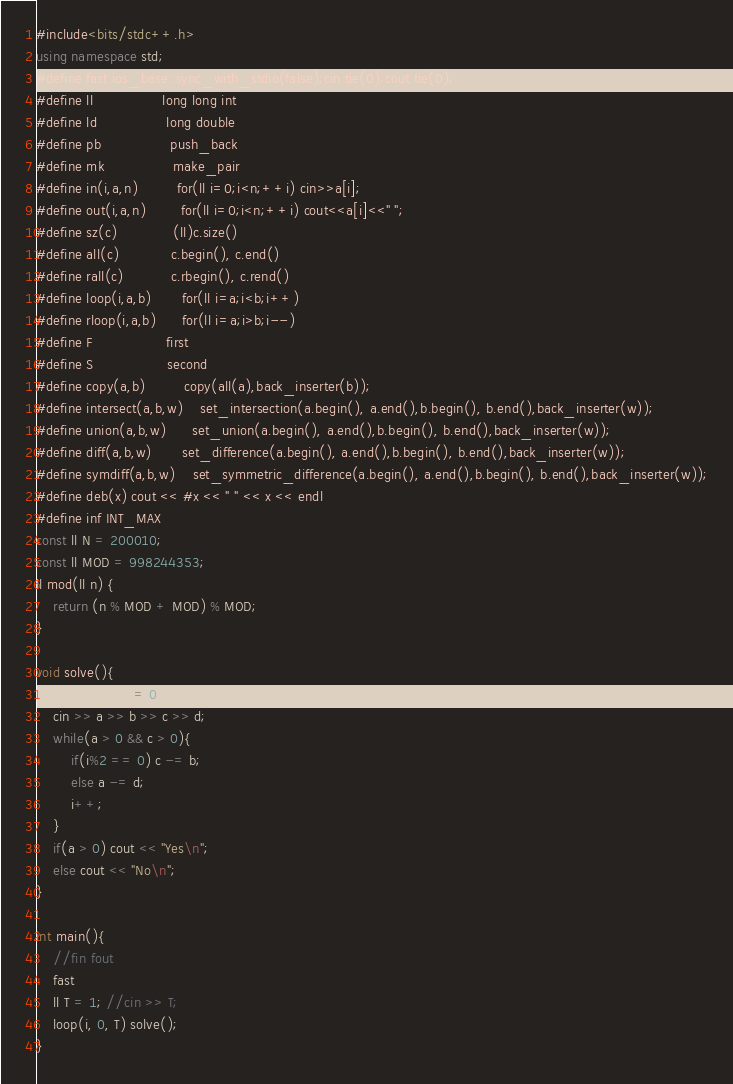<code> <loc_0><loc_0><loc_500><loc_500><_C++_>#include<bits/stdc++.h>
using namespace std;
#define fast ios_base::sync_with_stdio(false);cin.tie(0);cout.tie(0);
#define ll                long long int
#define ld                long double
#define pb                push_back
#define mk                make_pair
#define in(i,a,n)         for(ll i=0;i<n;++i) cin>>a[i];
#define out(i,a,n)        for(ll i=0;i<n;++i) cout<<a[i]<<" ";
#define sz(c)             (ll)c.size()
#define all(c)            c.begin(), c.end()
#define rall(c)           c.rbegin(), c.rend()
#define loop(i,a,b)       for(ll i=a;i<b;i++)
#define rloop(i,a,b)      for(ll i=a;i>b;i--)
#define F                 first
#define S                 second
#define copy(a,b)         copy(all(a),back_inserter(b));
#define intersect(a,b,w)    set_intersection(a.begin(), a.end(),b.begin(), b.end(),back_inserter(w));
#define union(a,b,w)      set_union(a.begin(), a.end(),b.begin(), b.end(),back_inserter(w));
#define diff(a,b,w)       set_difference(a.begin(), a.end(),b.begin(), b.end(),back_inserter(w));
#define symdiff(a,b,w)    set_symmetric_difference(a.begin(), a.end(),b.begin(), b.end(),back_inserter(w));
#define deb(x) cout << #x << " " << x << endl
#define inf INT_MAX
const ll N = 200010;
const ll MOD = 998244353;
ll mod(ll n) {
    return (n % MOD + MOD) % MOD;
}

void solve(){
    ll a, b, c, d, i = 0;
    cin >> a >> b >> c >> d;
    while(a > 0 && c > 0){
        if(i%2 == 0) c -= b;
        else a -= d;
        i++;
    }
    if(a > 0) cout << "Yes\n";
    else cout << "No\n";
}

int main(){
    //fin fout
    fast
    ll T = 1; //cin >> T;
    loop(i, 0, T) solve();
}
</code> 